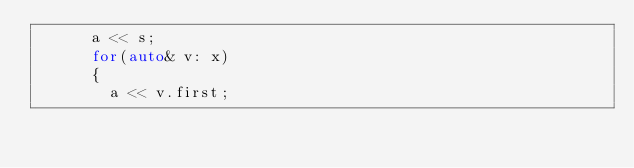<code> <loc_0><loc_0><loc_500><loc_500><_C_>      a << s;
      for(auto& v: x)
      {
        a << v.first;</code> 